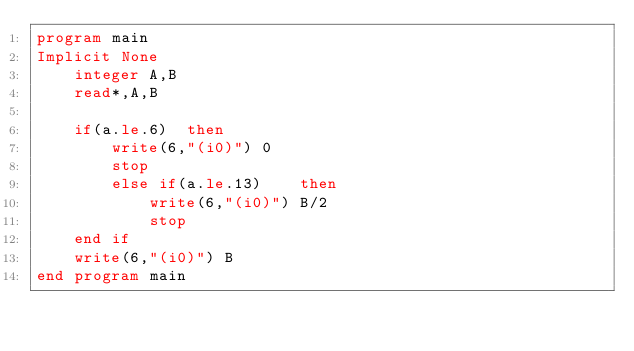Convert code to text. <code><loc_0><loc_0><loc_500><loc_500><_FORTRAN_>program main
Implicit None
	integer A,B
	read*,A,B
	
	if(a.le.6)	then
		write(6,"(i0)") 0
		stop
		else if(a.le.13)	then
			write(6,"(i0)") B/2
			stop
	end if
	write(6,"(i0)") B
end program main</code> 